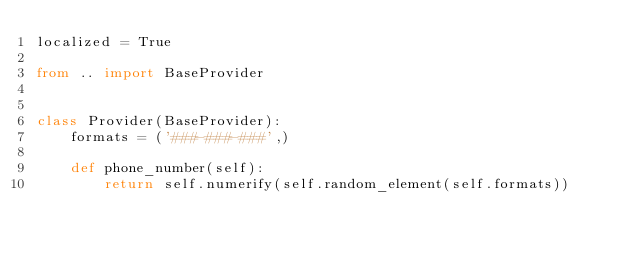Convert code to text. <code><loc_0><loc_0><loc_500><loc_500><_Python_>localized = True

from .. import BaseProvider


class Provider(BaseProvider):
    formats = ('###-###-###',)

    def phone_number(self):
        return self.numerify(self.random_element(self.formats))
</code> 